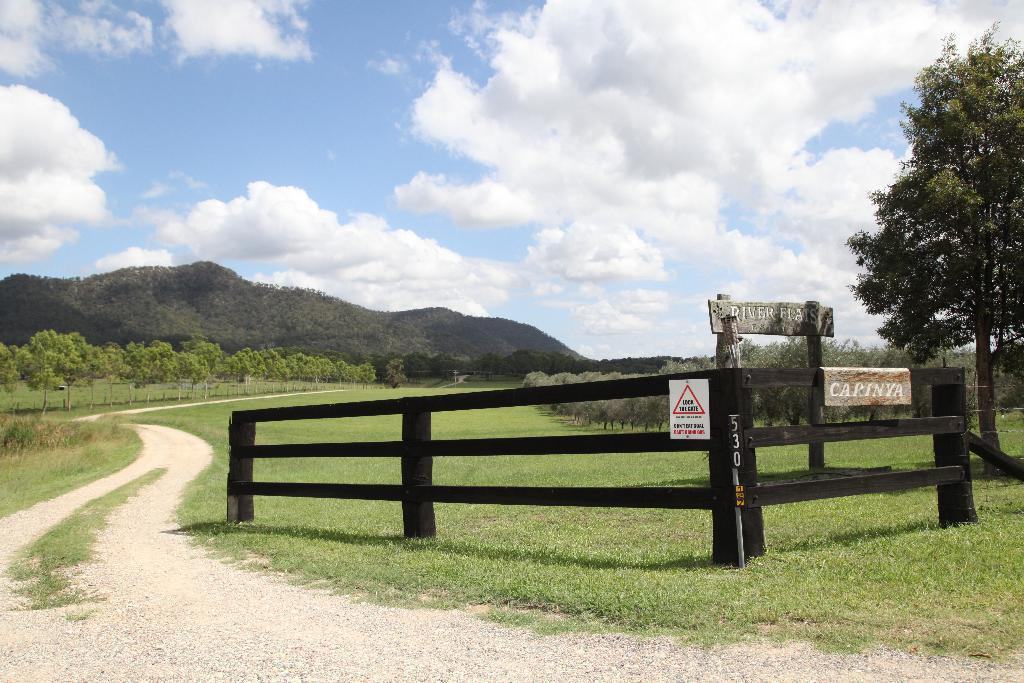What type of vegetation is present in the image? There is grass in the image. What type of structure can be seen in the image? There is a fence in the image. What objects are made of wood in the image? There are boards in the image. What type of natural feature is visible in the image? There is a mountain in the image. What is visible in the background of the image? The sky is visible in the background of the image. What is the weather like in the image? The sky has heavy clouds, suggesting a potentially stormy or overcast day. Can you see the partner of the goat in the image? There is no goat present in the image, so it is not possible to see its partner. What type of cord is used to hold the mountain in place in the image? There is no cord present in the image, and the mountain is a natural feature that does not require any support. 